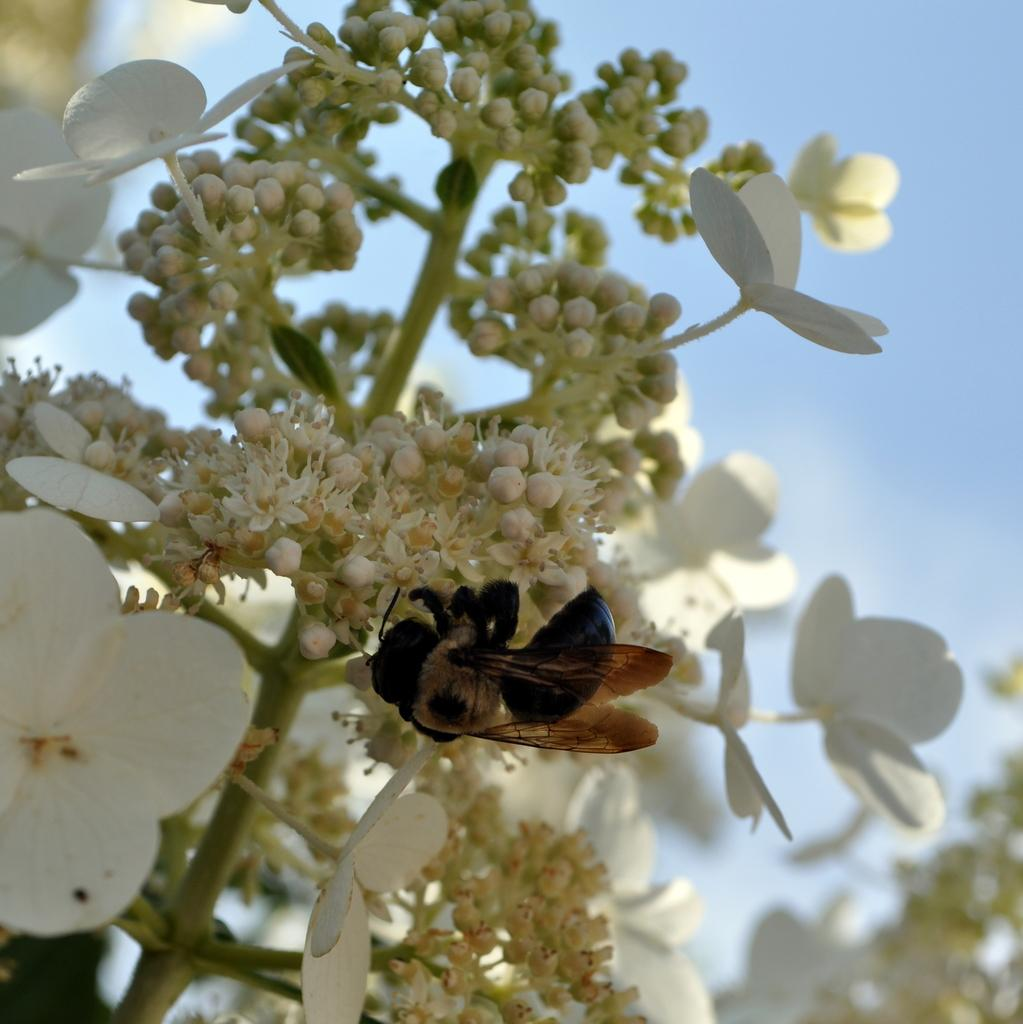What color are the flowers in the image? The flowers in the image are white. What stage of growth are the flowers in? There are white color buds in the image, indicating that some flowers are still in the bud stage. What can be seen in the background of the image? The sky is visible in the background of the image. How would you describe the clarity of the image? The image appears to be slightly blurry in the background. What is the daughter's name in the image? There is no daughter present in the image, so it is not possible to determine her name. 